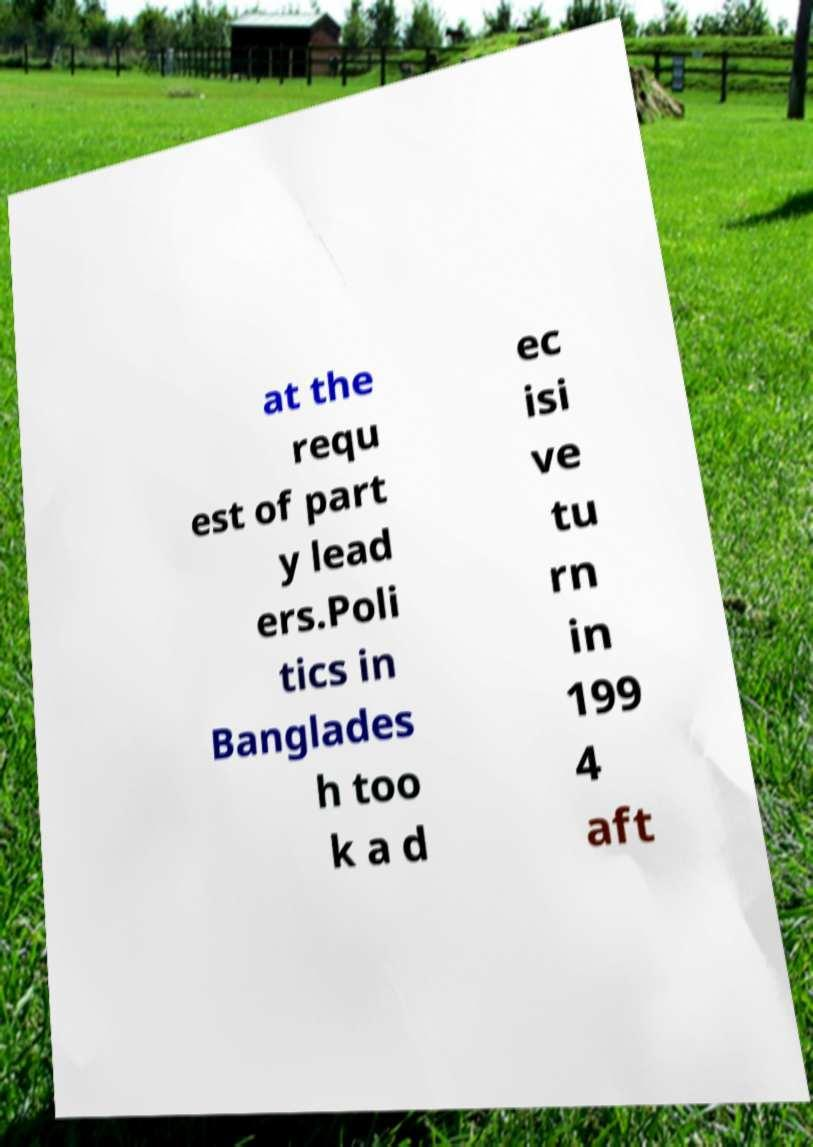Please identify and transcribe the text found in this image. at the requ est of part y lead ers.Poli tics in Banglades h too k a d ec isi ve tu rn in 199 4 aft 